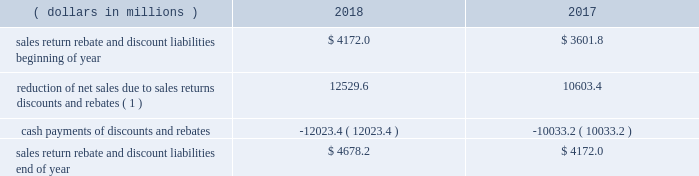Financial statement impact we believe that our accruals for sales returns , rebates , and discounts are reasonable and appropriate based on current facts and circumstances .
Our global rebate and discount liabilities are included in sales rebates and discounts on our consolidated balance sheet .
Our global sales return liability is included in other current liabilities and other noncurrent liabilities on our consolidated balance sheet .
As of december 31 , 2018 , a 5 percent change in our global sales return , rebate , and discount liability would have led to an approximate $ 275 million effect on our income before income taxes .
The portion of our global sales return , rebate , and discount liability resulting from sales of our products in the u.s .
Was approximately 90 percent as of december 31 , 2018 and december 31 , 2017 .
The following represents a roll-forward of our most significant u.s .
Pharmaceutical sales return , rebate , and discount liability balances , including managed care , medicare , and medicaid: .
( 1 ) adjustments of the estimates for these returns , rebates , and discounts to actual results were approximately 1 percent of consolidated net sales for each of the years presented .
Product litigation liabilities and other contingencies background and uncertainties product litigation liabilities and other contingencies are , by their nature , uncertain and based upon complex judgments and probabilities .
The factors we consider in developing our product litigation liability reserves and other contingent liability amounts include the merits and jurisdiction of the litigation , the nature and the number of other similar current and past matters , the nature of the product and the current assessment of the science subject to the litigation , and the likelihood of settlement and current state of settlement discussions , if any .
In addition , we accrue for certain product liability claims incurred , but not filed , to the extent we can formulate a reasonable estimate of their costs based primarily on historical claims experience and data regarding product usage .
We accrue legal defense costs expected to be incurred in connection with significant product liability contingencies when both probable and reasonably estimable .
We also consider the insurance coverage we have to diminish the exposure for periods covered by insurance .
In assessing our insurance coverage , we consider the policy coverage limits and exclusions , the potential for denial of coverage by the insurance company , the financial condition of the insurers , and the possibility of and length of time for collection .
Due to a very restrictive market for product liability insurance , we are self-insured for product liability losses for all our currently marketed products .
In addition to insurance coverage , we also consider any third-party indemnification to which we are entitled or under which we are obligated .
With respect to our third-party indemnification rights , these considerations include the nature of the indemnification , the financial condition of the indemnifying party , and the possibility of and length of time for collection .
The litigation accruals and environmental liabilities and the related estimated insurance recoverables have been reflected on a gross basis as liabilities and assets , respectively , on our consolidated balance sheets .
Impairment of indefinite-lived and long-lived assets background and uncertainties we review the carrying value of long-lived assets ( both intangible and tangible ) for potential impairment on a periodic basis and whenever events or changes in circumstances indicate the carrying value of an asset ( or asset group ) may not be recoverable .
We identify impairment by comparing the projected undiscounted cash flows to be generated by the asset ( or asset group ) to its carrying value .
If an impairment is identified , a loss is recorded equal to the excess of the asset 2019s net book value over its fair value , and the cost basis is adjusted .
Goodwill and indefinite-lived intangible assets are reviewed for impairment at least annually and when certain impairment indicators are present .
When required , a comparison of fair value to the carrying amount of assets is performed to determine the amount of any impairment. .
What was the percentage change in reduction of net sales due to sales returns discounts and rebates between 2017 and 2018? 
Computations: ((12529.6 - 10603.4) / 10603.4)
Answer: 0.18166. 